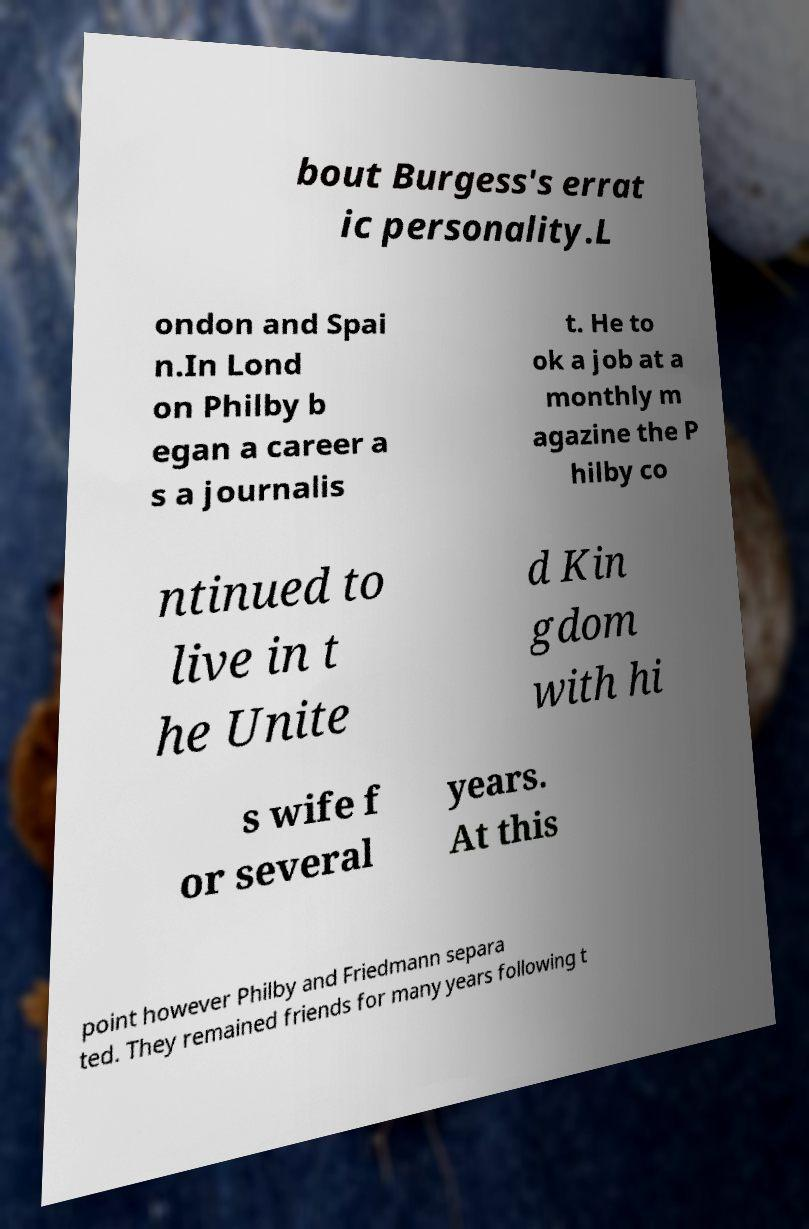What messages or text are displayed in this image? I need them in a readable, typed format. bout Burgess's errat ic personality.L ondon and Spai n.In Lond on Philby b egan a career a s a journalis t. He to ok a job at a monthly m agazine the P hilby co ntinued to live in t he Unite d Kin gdom with hi s wife f or several years. At this point however Philby and Friedmann separa ted. They remained friends for many years following t 